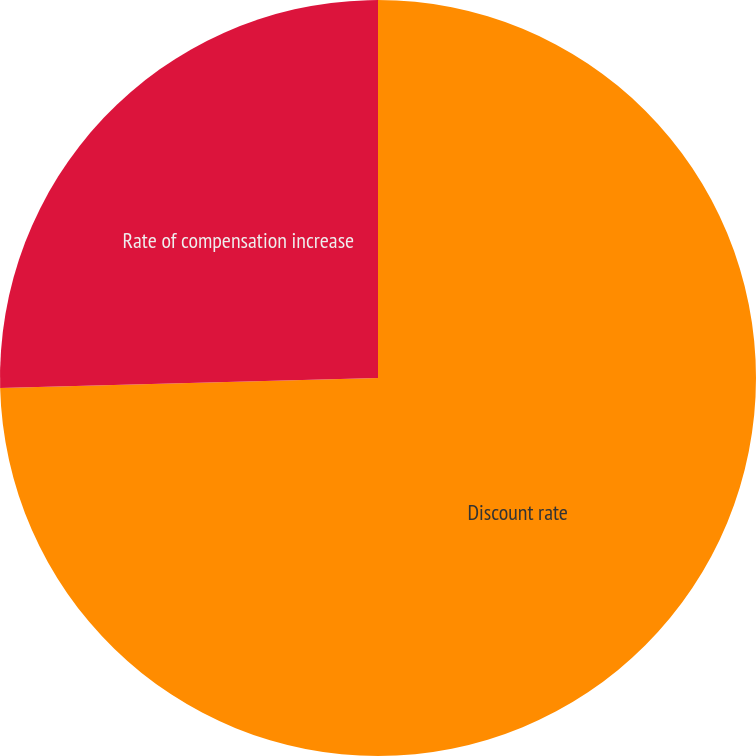<chart> <loc_0><loc_0><loc_500><loc_500><pie_chart><fcel>Discount rate<fcel>Rate of compensation increase<nl><fcel>74.58%<fcel>25.42%<nl></chart> 